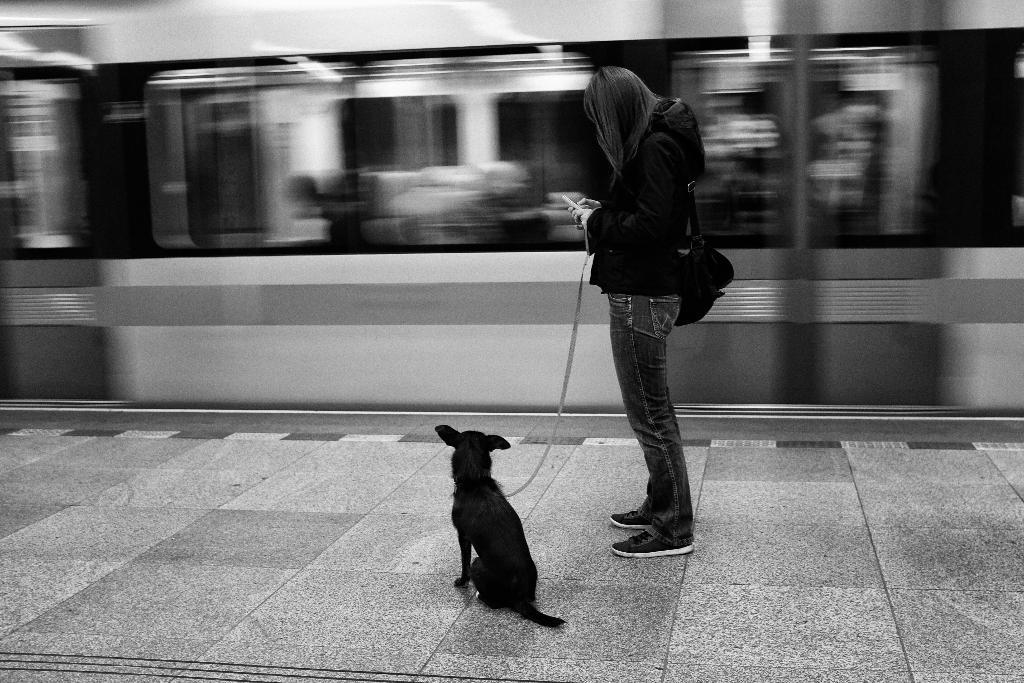What is the person in the image doing? The person is standing in the image. What is the person wearing in the image? The person is wearing a bag and holding the belt of a black dog. Where is the scene taking place? The scene takes place on a platform. What can be seen in the background of the image? A train is passing in the background. What is the woman wearing on her upper body? The woman is wearing a black t-shirt. What type of pants is the woman wearing? The woman is wearing jeans. What type of yarn is the woman using to knit a sweater in the image? There is no yarn or sweater present in the image; the woman is holding the belt of a black dog. Is the woman's dad in the image? There is no mention of a dad or any other person in the image, only the woman and the black dog. 